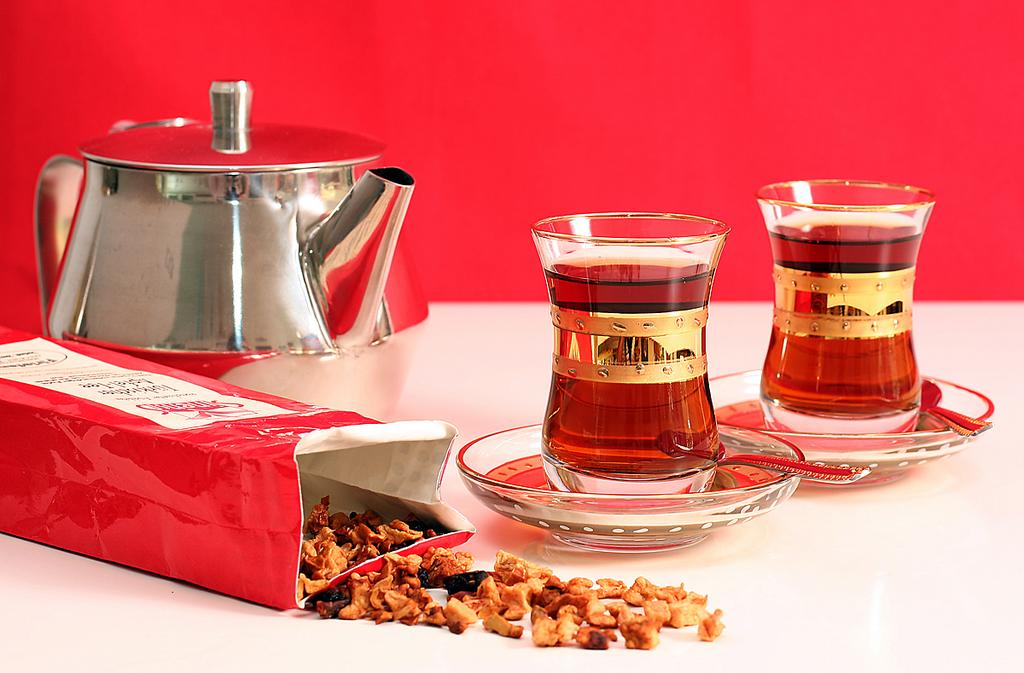What type of objects can be seen with drinks in the image? There are glasses with drinks in the image. What utensils are present in the image? There are spoons in the image. What type of tableware is visible in the image? There are dishes in the image. What type of food items can be seen in the image? There are food items in the image. What other objects can be seen in the image? There is a box and a kettle in the image. On what surface are all these objects placed? All of these objects are placed on a white platform. What is the color of the background in the image? The background of the image is red. What type of quilt is being used to play with the food items in the image? There is no quilt or playing activity involving food items present in the image. 